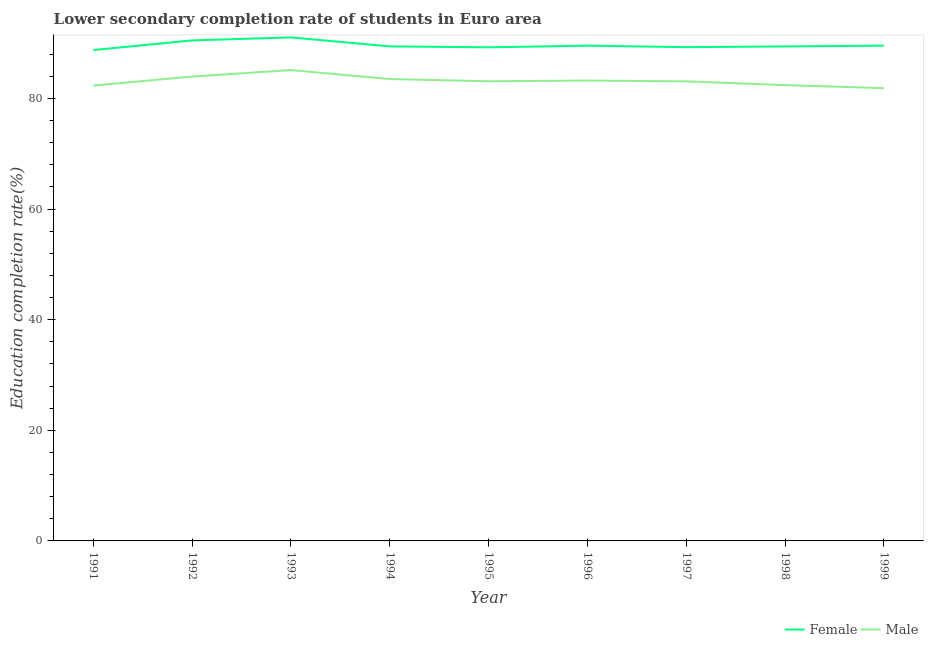How many different coloured lines are there?
Provide a short and direct response. 2. Does the line corresponding to education completion rate of female students intersect with the line corresponding to education completion rate of male students?
Your answer should be very brief. No. What is the education completion rate of male students in 1995?
Provide a short and direct response. 83.1. Across all years, what is the maximum education completion rate of male students?
Your answer should be compact. 85.12. Across all years, what is the minimum education completion rate of female students?
Provide a short and direct response. 88.73. In which year was the education completion rate of male students maximum?
Provide a short and direct response. 1993. In which year was the education completion rate of female students minimum?
Your answer should be compact. 1991. What is the total education completion rate of female students in the graph?
Ensure brevity in your answer.  806.6. What is the difference between the education completion rate of male students in 1991 and that in 1996?
Your answer should be compact. -0.9. What is the difference between the education completion rate of female students in 1994 and the education completion rate of male students in 1999?
Give a very brief answer. 7.55. What is the average education completion rate of male students per year?
Keep it short and to the point. 83.17. In the year 1995, what is the difference between the education completion rate of female students and education completion rate of male students?
Make the answer very short. 6.13. In how many years, is the education completion rate of male students greater than 32 %?
Offer a very short reply. 9. What is the ratio of the education completion rate of male students in 1991 to that in 1995?
Ensure brevity in your answer.  0.99. Is the education completion rate of male students in 1993 less than that in 1996?
Offer a terse response. No. Is the difference between the education completion rate of male students in 1992 and 1997 greater than the difference between the education completion rate of female students in 1992 and 1997?
Your answer should be compact. No. What is the difference between the highest and the second highest education completion rate of female students?
Your response must be concise. 0.54. What is the difference between the highest and the lowest education completion rate of female students?
Your response must be concise. 2.29. In how many years, is the education completion rate of male students greater than the average education completion rate of male students taken over all years?
Offer a very short reply. 4. Is the sum of the education completion rate of male students in 1997 and 1998 greater than the maximum education completion rate of female students across all years?
Offer a terse response. Yes. Is the education completion rate of male students strictly less than the education completion rate of female students over the years?
Your answer should be compact. Yes. How many lines are there?
Your answer should be compact. 2. What is the difference between two consecutive major ticks on the Y-axis?
Ensure brevity in your answer.  20. Are the values on the major ticks of Y-axis written in scientific E-notation?
Offer a terse response. No. Where does the legend appear in the graph?
Provide a succinct answer. Bottom right. How many legend labels are there?
Your answer should be compact. 2. How are the legend labels stacked?
Ensure brevity in your answer.  Horizontal. What is the title of the graph?
Provide a succinct answer. Lower secondary completion rate of students in Euro area. Does "Male" appear as one of the legend labels in the graph?
Your answer should be very brief. Yes. What is the label or title of the X-axis?
Provide a succinct answer. Year. What is the label or title of the Y-axis?
Offer a very short reply. Education completion rate(%). What is the Education completion rate(%) in Female in 1991?
Offer a terse response. 88.73. What is the Education completion rate(%) in Male in 1991?
Keep it short and to the point. 82.32. What is the Education completion rate(%) in Female in 1992?
Keep it short and to the point. 90.48. What is the Education completion rate(%) in Male in 1992?
Your response must be concise. 83.95. What is the Education completion rate(%) of Female in 1993?
Ensure brevity in your answer.  91.02. What is the Education completion rate(%) in Male in 1993?
Give a very brief answer. 85.12. What is the Education completion rate(%) in Female in 1994?
Keep it short and to the point. 89.4. What is the Education completion rate(%) in Male in 1994?
Your answer should be compact. 83.5. What is the Education completion rate(%) of Female in 1995?
Offer a very short reply. 89.23. What is the Education completion rate(%) of Male in 1995?
Offer a terse response. 83.1. What is the Education completion rate(%) in Female in 1996?
Offer a terse response. 89.53. What is the Education completion rate(%) in Male in 1996?
Provide a short and direct response. 83.22. What is the Education completion rate(%) of Female in 1997?
Give a very brief answer. 89.26. What is the Education completion rate(%) in Male in 1997?
Provide a succinct answer. 83.08. What is the Education completion rate(%) of Female in 1998?
Offer a very short reply. 89.4. What is the Education completion rate(%) of Male in 1998?
Offer a terse response. 82.4. What is the Education completion rate(%) in Female in 1999?
Make the answer very short. 89.53. What is the Education completion rate(%) in Male in 1999?
Your response must be concise. 81.85. Across all years, what is the maximum Education completion rate(%) of Female?
Give a very brief answer. 91.02. Across all years, what is the maximum Education completion rate(%) of Male?
Keep it short and to the point. 85.12. Across all years, what is the minimum Education completion rate(%) of Female?
Provide a succinct answer. 88.73. Across all years, what is the minimum Education completion rate(%) of Male?
Ensure brevity in your answer.  81.85. What is the total Education completion rate(%) in Female in the graph?
Make the answer very short. 806.6. What is the total Education completion rate(%) in Male in the graph?
Offer a very short reply. 748.53. What is the difference between the Education completion rate(%) in Female in 1991 and that in 1992?
Ensure brevity in your answer.  -1.75. What is the difference between the Education completion rate(%) of Male in 1991 and that in 1992?
Your answer should be compact. -1.63. What is the difference between the Education completion rate(%) of Female in 1991 and that in 1993?
Offer a very short reply. -2.29. What is the difference between the Education completion rate(%) in Male in 1991 and that in 1993?
Offer a terse response. -2.8. What is the difference between the Education completion rate(%) of Female in 1991 and that in 1994?
Your answer should be compact. -0.67. What is the difference between the Education completion rate(%) in Male in 1991 and that in 1994?
Your response must be concise. -1.18. What is the difference between the Education completion rate(%) of Female in 1991 and that in 1995?
Your answer should be very brief. -0.5. What is the difference between the Education completion rate(%) in Male in 1991 and that in 1995?
Provide a short and direct response. -0.78. What is the difference between the Education completion rate(%) of Female in 1991 and that in 1996?
Keep it short and to the point. -0.8. What is the difference between the Education completion rate(%) of Male in 1991 and that in 1996?
Your response must be concise. -0.9. What is the difference between the Education completion rate(%) of Female in 1991 and that in 1997?
Give a very brief answer. -0.52. What is the difference between the Education completion rate(%) of Male in 1991 and that in 1997?
Your answer should be compact. -0.76. What is the difference between the Education completion rate(%) in Female in 1991 and that in 1998?
Your answer should be compact. -0.66. What is the difference between the Education completion rate(%) of Male in 1991 and that in 1998?
Give a very brief answer. -0.08. What is the difference between the Education completion rate(%) in Female in 1991 and that in 1999?
Provide a short and direct response. -0.8. What is the difference between the Education completion rate(%) in Male in 1991 and that in 1999?
Your response must be concise. 0.46. What is the difference between the Education completion rate(%) of Female in 1992 and that in 1993?
Provide a short and direct response. -0.54. What is the difference between the Education completion rate(%) of Male in 1992 and that in 1993?
Your answer should be compact. -1.17. What is the difference between the Education completion rate(%) of Female in 1992 and that in 1994?
Your answer should be compact. 1.08. What is the difference between the Education completion rate(%) in Male in 1992 and that in 1994?
Provide a succinct answer. 0.45. What is the difference between the Education completion rate(%) in Female in 1992 and that in 1995?
Ensure brevity in your answer.  1.25. What is the difference between the Education completion rate(%) of Male in 1992 and that in 1995?
Offer a terse response. 0.85. What is the difference between the Education completion rate(%) of Female in 1992 and that in 1996?
Keep it short and to the point. 0.95. What is the difference between the Education completion rate(%) in Male in 1992 and that in 1996?
Ensure brevity in your answer.  0.73. What is the difference between the Education completion rate(%) of Female in 1992 and that in 1997?
Keep it short and to the point. 1.22. What is the difference between the Education completion rate(%) in Male in 1992 and that in 1997?
Ensure brevity in your answer.  0.87. What is the difference between the Education completion rate(%) of Female in 1992 and that in 1998?
Offer a terse response. 1.09. What is the difference between the Education completion rate(%) in Male in 1992 and that in 1998?
Offer a very short reply. 1.55. What is the difference between the Education completion rate(%) in Female in 1992 and that in 1999?
Your answer should be compact. 0.95. What is the difference between the Education completion rate(%) in Male in 1992 and that in 1999?
Keep it short and to the point. 2.09. What is the difference between the Education completion rate(%) in Female in 1993 and that in 1994?
Your answer should be compact. 1.62. What is the difference between the Education completion rate(%) in Male in 1993 and that in 1994?
Your answer should be very brief. 1.61. What is the difference between the Education completion rate(%) of Female in 1993 and that in 1995?
Your answer should be compact. 1.79. What is the difference between the Education completion rate(%) of Male in 1993 and that in 1995?
Make the answer very short. 2.02. What is the difference between the Education completion rate(%) of Female in 1993 and that in 1996?
Your response must be concise. 1.49. What is the difference between the Education completion rate(%) of Male in 1993 and that in 1996?
Keep it short and to the point. 1.89. What is the difference between the Education completion rate(%) in Female in 1993 and that in 1997?
Your answer should be very brief. 1.77. What is the difference between the Education completion rate(%) of Male in 1993 and that in 1997?
Offer a terse response. 2.04. What is the difference between the Education completion rate(%) in Female in 1993 and that in 1998?
Provide a succinct answer. 1.63. What is the difference between the Education completion rate(%) in Male in 1993 and that in 1998?
Provide a succinct answer. 2.72. What is the difference between the Education completion rate(%) in Female in 1993 and that in 1999?
Provide a succinct answer. 1.49. What is the difference between the Education completion rate(%) in Male in 1993 and that in 1999?
Ensure brevity in your answer.  3.26. What is the difference between the Education completion rate(%) of Female in 1994 and that in 1995?
Provide a short and direct response. 0.17. What is the difference between the Education completion rate(%) in Male in 1994 and that in 1995?
Offer a terse response. 0.41. What is the difference between the Education completion rate(%) of Female in 1994 and that in 1996?
Keep it short and to the point. -0.13. What is the difference between the Education completion rate(%) of Male in 1994 and that in 1996?
Ensure brevity in your answer.  0.28. What is the difference between the Education completion rate(%) of Female in 1994 and that in 1997?
Your answer should be very brief. 0.15. What is the difference between the Education completion rate(%) in Male in 1994 and that in 1997?
Your response must be concise. 0.42. What is the difference between the Education completion rate(%) of Female in 1994 and that in 1998?
Keep it short and to the point. 0.01. What is the difference between the Education completion rate(%) in Male in 1994 and that in 1998?
Provide a short and direct response. 1.1. What is the difference between the Education completion rate(%) in Female in 1994 and that in 1999?
Give a very brief answer. -0.13. What is the difference between the Education completion rate(%) in Male in 1994 and that in 1999?
Keep it short and to the point. 1.65. What is the difference between the Education completion rate(%) in Female in 1995 and that in 1996?
Offer a terse response. -0.3. What is the difference between the Education completion rate(%) of Male in 1995 and that in 1996?
Offer a terse response. -0.13. What is the difference between the Education completion rate(%) of Female in 1995 and that in 1997?
Give a very brief answer. -0.03. What is the difference between the Education completion rate(%) in Male in 1995 and that in 1997?
Ensure brevity in your answer.  0.02. What is the difference between the Education completion rate(%) of Female in 1995 and that in 1998?
Make the answer very short. -0.17. What is the difference between the Education completion rate(%) of Male in 1995 and that in 1998?
Your response must be concise. 0.7. What is the difference between the Education completion rate(%) of Female in 1995 and that in 1999?
Provide a succinct answer. -0.3. What is the difference between the Education completion rate(%) in Male in 1995 and that in 1999?
Provide a short and direct response. 1.24. What is the difference between the Education completion rate(%) in Female in 1996 and that in 1997?
Keep it short and to the point. 0.28. What is the difference between the Education completion rate(%) in Male in 1996 and that in 1997?
Offer a terse response. 0.14. What is the difference between the Education completion rate(%) of Female in 1996 and that in 1998?
Your response must be concise. 0.14. What is the difference between the Education completion rate(%) of Male in 1996 and that in 1998?
Your response must be concise. 0.82. What is the difference between the Education completion rate(%) of Female in 1996 and that in 1999?
Make the answer very short. -0. What is the difference between the Education completion rate(%) in Male in 1996 and that in 1999?
Your answer should be very brief. 1.37. What is the difference between the Education completion rate(%) of Female in 1997 and that in 1998?
Make the answer very short. -0.14. What is the difference between the Education completion rate(%) of Male in 1997 and that in 1998?
Keep it short and to the point. 0.68. What is the difference between the Education completion rate(%) of Female in 1997 and that in 1999?
Your answer should be very brief. -0.28. What is the difference between the Education completion rate(%) in Male in 1997 and that in 1999?
Keep it short and to the point. 1.23. What is the difference between the Education completion rate(%) in Female in 1998 and that in 1999?
Ensure brevity in your answer.  -0.14. What is the difference between the Education completion rate(%) in Male in 1998 and that in 1999?
Your response must be concise. 0.54. What is the difference between the Education completion rate(%) of Female in 1991 and the Education completion rate(%) of Male in 1992?
Make the answer very short. 4.79. What is the difference between the Education completion rate(%) in Female in 1991 and the Education completion rate(%) in Male in 1993?
Offer a very short reply. 3.62. What is the difference between the Education completion rate(%) in Female in 1991 and the Education completion rate(%) in Male in 1994?
Keep it short and to the point. 5.23. What is the difference between the Education completion rate(%) in Female in 1991 and the Education completion rate(%) in Male in 1995?
Your answer should be very brief. 5.64. What is the difference between the Education completion rate(%) in Female in 1991 and the Education completion rate(%) in Male in 1996?
Offer a terse response. 5.51. What is the difference between the Education completion rate(%) in Female in 1991 and the Education completion rate(%) in Male in 1997?
Your answer should be very brief. 5.65. What is the difference between the Education completion rate(%) of Female in 1991 and the Education completion rate(%) of Male in 1998?
Your answer should be very brief. 6.33. What is the difference between the Education completion rate(%) in Female in 1991 and the Education completion rate(%) in Male in 1999?
Offer a very short reply. 6.88. What is the difference between the Education completion rate(%) of Female in 1992 and the Education completion rate(%) of Male in 1993?
Your answer should be compact. 5.37. What is the difference between the Education completion rate(%) in Female in 1992 and the Education completion rate(%) in Male in 1994?
Keep it short and to the point. 6.98. What is the difference between the Education completion rate(%) in Female in 1992 and the Education completion rate(%) in Male in 1995?
Keep it short and to the point. 7.39. What is the difference between the Education completion rate(%) of Female in 1992 and the Education completion rate(%) of Male in 1996?
Your response must be concise. 7.26. What is the difference between the Education completion rate(%) of Female in 1992 and the Education completion rate(%) of Male in 1997?
Ensure brevity in your answer.  7.4. What is the difference between the Education completion rate(%) in Female in 1992 and the Education completion rate(%) in Male in 1998?
Your answer should be compact. 8.08. What is the difference between the Education completion rate(%) in Female in 1992 and the Education completion rate(%) in Male in 1999?
Keep it short and to the point. 8.63. What is the difference between the Education completion rate(%) in Female in 1993 and the Education completion rate(%) in Male in 1994?
Offer a very short reply. 7.52. What is the difference between the Education completion rate(%) of Female in 1993 and the Education completion rate(%) of Male in 1995?
Keep it short and to the point. 7.93. What is the difference between the Education completion rate(%) in Female in 1993 and the Education completion rate(%) in Male in 1996?
Provide a succinct answer. 7.8. What is the difference between the Education completion rate(%) of Female in 1993 and the Education completion rate(%) of Male in 1997?
Give a very brief answer. 7.94. What is the difference between the Education completion rate(%) in Female in 1993 and the Education completion rate(%) in Male in 1998?
Provide a short and direct response. 8.63. What is the difference between the Education completion rate(%) of Female in 1993 and the Education completion rate(%) of Male in 1999?
Provide a succinct answer. 9.17. What is the difference between the Education completion rate(%) in Female in 1994 and the Education completion rate(%) in Male in 1995?
Offer a very short reply. 6.31. What is the difference between the Education completion rate(%) of Female in 1994 and the Education completion rate(%) of Male in 1996?
Your response must be concise. 6.18. What is the difference between the Education completion rate(%) in Female in 1994 and the Education completion rate(%) in Male in 1997?
Give a very brief answer. 6.32. What is the difference between the Education completion rate(%) of Female in 1994 and the Education completion rate(%) of Male in 1998?
Provide a succinct answer. 7.01. What is the difference between the Education completion rate(%) in Female in 1994 and the Education completion rate(%) in Male in 1999?
Provide a short and direct response. 7.55. What is the difference between the Education completion rate(%) of Female in 1995 and the Education completion rate(%) of Male in 1996?
Provide a succinct answer. 6.01. What is the difference between the Education completion rate(%) in Female in 1995 and the Education completion rate(%) in Male in 1997?
Make the answer very short. 6.15. What is the difference between the Education completion rate(%) in Female in 1995 and the Education completion rate(%) in Male in 1998?
Make the answer very short. 6.83. What is the difference between the Education completion rate(%) in Female in 1995 and the Education completion rate(%) in Male in 1999?
Make the answer very short. 7.38. What is the difference between the Education completion rate(%) of Female in 1996 and the Education completion rate(%) of Male in 1997?
Your response must be concise. 6.45. What is the difference between the Education completion rate(%) of Female in 1996 and the Education completion rate(%) of Male in 1998?
Your answer should be compact. 7.13. What is the difference between the Education completion rate(%) in Female in 1996 and the Education completion rate(%) in Male in 1999?
Offer a terse response. 7.68. What is the difference between the Education completion rate(%) in Female in 1997 and the Education completion rate(%) in Male in 1998?
Provide a succinct answer. 6.86. What is the difference between the Education completion rate(%) of Female in 1997 and the Education completion rate(%) of Male in 1999?
Provide a succinct answer. 7.4. What is the difference between the Education completion rate(%) of Female in 1998 and the Education completion rate(%) of Male in 1999?
Make the answer very short. 7.54. What is the average Education completion rate(%) in Female per year?
Your answer should be very brief. 89.62. What is the average Education completion rate(%) in Male per year?
Keep it short and to the point. 83.17. In the year 1991, what is the difference between the Education completion rate(%) in Female and Education completion rate(%) in Male?
Your answer should be very brief. 6.42. In the year 1992, what is the difference between the Education completion rate(%) of Female and Education completion rate(%) of Male?
Ensure brevity in your answer.  6.53. In the year 1993, what is the difference between the Education completion rate(%) of Female and Education completion rate(%) of Male?
Give a very brief answer. 5.91. In the year 1994, what is the difference between the Education completion rate(%) of Female and Education completion rate(%) of Male?
Provide a succinct answer. 5.9. In the year 1995, what is the difference between the Education completion rate(%) in Female and Education completion rate(%) in Male?
Provide a short and direct response. 6.13. In the year 1996, what is the difference between the Education completion rate(%) in Female and Education completion rate(%) in Male?
Make the answer very short. 6.31. In the year 1997, what is the difference between the Education completion rate(%) of Female and Education completion rate(%) of Male?
Your answer should be compact. 6.18. In the year 1998, what is the difference between the Education completion rate(%) in Female and Education completion rate(%) in Male?
Offer a very short reply. 7. In the year 1999, what is the difference between the Education completion rate(%) of Female and Education completion rate(%) of Male?
Provide a succinct answer. 7.68. What is the ratio of the Education completion rate(%) in Female in 1991 to that in 1992?
Provide a short and direct response. 0.98. What is the ratio of the Education completion rate(%) in Male in 1991 to that in 1992?
Provide a short and direct response. 0.98. What is the ratio of the Education completion rate(%) in Female in 1991 to that in 1993?
Provide a succinct answer. 0.97. What is the ratio of the Education completion rate(%) of Male in 1991 to that in 1993?
Your answer should be very brief. 0.97. What is the ratio of the Education completion rate(%) of Female in 1991 to that in 1994?
Provide a succinct answer. 0.99. What is the ratio of the Education completion rate(%) of Male in 1991 to that in 1994?
Your response must be concise. 0.99. What is the ratio of the Education completion rate(%) in Female in 1991 to that in 1995?
Provide a short and direct response. 0.99. What is the ratio of the Education completion rate(%) of Male in 1991 to that in 1995?
Keep it short and to the point. 0.99. What is the ratio of the Education completion rate(%) in Female in 1991 to that in 1996?
Keep it short and to the point. 0.99. What is the ratio of the Education completion rate(%) of Male in 1991 to that in 1996?
Offer a very short reply. 0.99. What is the ratio of the Education completion rate(%) in Male in 1991 to that in 1997?
Your answer should be compact. 0.99. What is the ratio of the Education completion rate(%) in Female in 1991 to that in 1998?
Your answer should be compact. 0.99. What is the ratio of the Education completion rate(%) of Male in 1991 to that in 1998?
Your answer should be very brief. 1. What is the ratio of the Education completion rate(%) in Male in 1991 to that in 1999?
Your answer should be very brief. 1.01. What is the ratio of the Education completion rate(%) in Female in 1992 to that in 1993?
Your answer should be very brief. 0.99. What is the ratio of the Education completion rate(%) in Male in 1992 to that in 1993?
Keep it short and to the point. 0.99. What is the ratio of the Education completion rate(%) of Female in 1992 to that in 1994?
Your answer should be very brief. 1.01. What is the ratio of the Education completion rate(%) of Male in 1992 to that in 1994?
Ensure brevity in your answer.  1.01. What is the ratio of the Education completion rate(%) in Female in 1992 to that in 1995?
Give a very brief answer. 1.01. What is the ratio of the Education completion rate(%) of Male in 1992 to that in 1995?
Keep it short and to the point. 1.01. What is the ratio of the Education completion rate(%) of Female in 1992 to that in 1996?
Your response must be concise. 1.01. What is the ratio of the Education completion rate(%) in Male in 1992 to that in 1996?
Provide a short and direct response. 1.01. What is the ratio of the Education completion rate(%) of Female in 1992 to that in 1997?
Offer a very short reply. 1.01. What is the ratio of the Education completion rate(%) of Male in 1992 to that in 1997?
Offer a very short reply. 1.01. What is the ratio of the Education completion rate(%) in Female in 1992 to that in 1998?
Provide a succinct answer. 1.01. What is the ratio of the Education completion rate(%) in Male in 1992 to that in 1998?
Your response must be concise. 1.02. What is the ratio of the Education completion rate(%) of Female in 1992 to that in 1999?
Make the answer very short. 1.01. What is the ratio of the Education completion rate(%) of Male in 1992 to that in 1999?
Keep it short and to the point. 1.03. What is the ratio of the Education completion rate(%) in Female in 1993 to that in 1994?
Offer a very short reply. 1.02. What is the ratio of the Education completion rate(%) in Male in 1993 to that in 1994?
Give a very brief answer. 1.02. What is the ratio of the Education completion rate(%) in Female in 1993 to that in 1995?
Keep it short and to the point. 1.02. What is the ratio of the Education completion rate(%) in Male in 1993 to that in 1995?
Make the answer very short. 1.02. What is the ratio of the Education completion rate(%) in Female in 1993 to that in 1996?
Ensure brevity in your answer.  1.02. What is the ratio of the Education completion rate(%) of Male in 1993 to that in 1996?
Your response must be concise. 1.02. What is the ratio of the Education completion rate(%) of Female in 1993 to that in 1997?
Provide a succinct answer. 1.02. What is the ratio of the Education completion rate(%) of Male in 1993 to that in 1997?
Offer a terse response. 1.02. What is the ratio of the Education completion rate(%) in Female in 1993 to that in 1998?
Ensure brevity in your answer.  1.02. What is the ratio of the Education completion rate(%) in Male in 1993 to that in 1998?
Provide a short and direct response. 1.03. What is the ratio of the Education completion rate(%) in Female in 1993 to that in 1999?
Keep it short and to the point. 1.02. What is the ratio of the Education completion rate(%) of Male in 1993 to that in 1999?
Make the answer very short. 1.04. What is the ratio of the Education completion rate(%) of Female in 1994 to that in 1995?
Offer a very short reply. 1. What is the ratio of the Education completion rate(%) in Male in 1994 to that in 1995?
Make the answer very short. 1. What is the ratio of the Education completion rate(%) in Female in 1994 to that in 1997?
Offer a very short reply. 1. What is the ratio of the Education completion rate(%) in Male in 1994 to that in 1997?
Your answer should be compact. 1.01. What is the ratio of the Education completion rate(%) in Male in 1994 to that in 1998?
Your response must be concise. 1.01. What is the ratio of the Education completion rate(%) of Male in 1994 to that in 1999?
Your response must be concise. 1.02. What is the ratio of the Education completion rate(%) of Female in 1995 to that in 1996?
Offer a very short reply. 1. What is the ratio of the Education completion rate(%) of Female in 1995 to that in 1997?
Ensure brevity in your answer.  1. What is the ratio of the Education completion rate(%) of Female in 1995 to that in 1998?
Provide a succinct answer. 1. What is the ratio of the Education completion rate(%) in Male in 1995 to that in 1998?
Offer a very short reply. 1.01. What is the ratio of the Education completion rate(%) in Male in 1995 to that in 1999?
Your answer should be compact. 1.02. What is the ratio of the Education completion rate(%) in Female in 1996 to that in 1997?
Offer a terse response. 1. What is the ratio of the Education completion rate(%) in Male in 1996 to that in 1998?
Provide a short and direct response. 1.01. What is the ratio of the Education completion rate(%) in Male in 1996 to that in 1999?
Your answer should be compact. 1.02. What is the ratio of the Education completion rate(%) of Male in 1997 to that in 1998?
Your answer should be very brief. 1.01. What is the ratio of the Education completion rate(%) in Female in 1997 to that in 1999?
Offer a very short reply. 1. What is the difference between the highest and the second highest Education completion rate(%) in Female?
Your response must be concise. 0.54. What is the difference between the highest and the second highest Education completion rate(%) of Male?
Provide a short and direct response. 1.17. What is the difference between the highest and the lowest Education completion rate(%) in Female?
Make the answer very short. 2.29. What is the difference between the highest and the lowest Education completion rate(%) of Male?
Give a very brief answer. 3.26. 